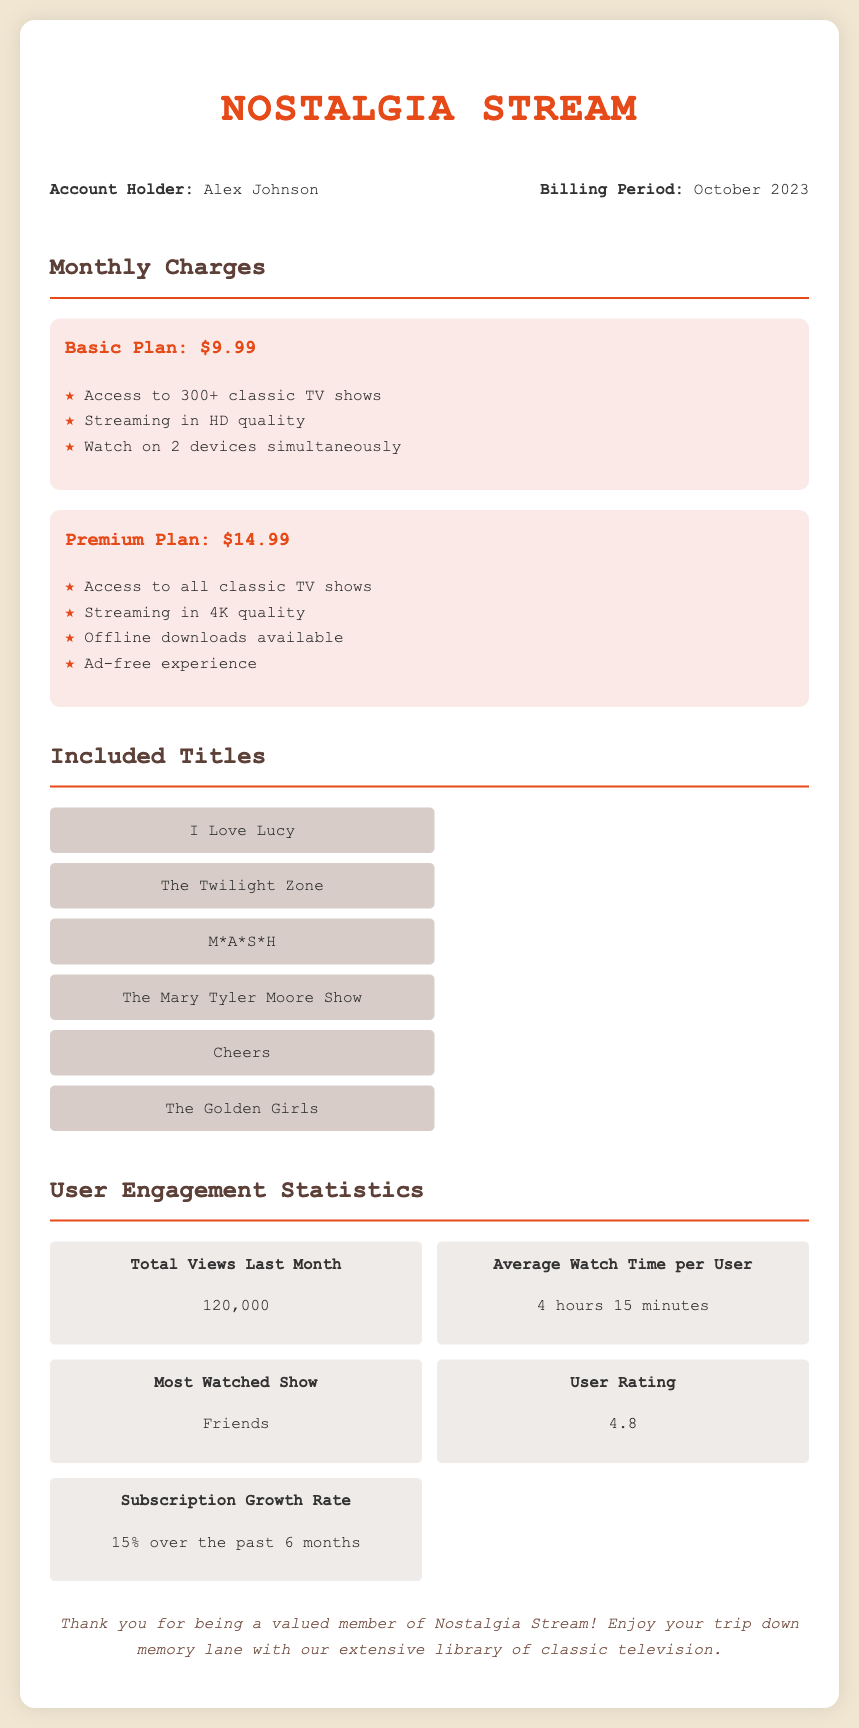what is the account holder's name? The account holder's name is stated in the document as Alex Johnson.
Answer: Alex Johnson what is the monthly charge for the Premium Plan? The document clearly states the monthly charge for the Premium Plan as $14.99.
Answer: $14.99 how many classic TV shows can be accessed with the Basic Plan? According to the information in the document, the Basic Plan provides access to 300+ classic TV shows.
Answer: 300+ what is the most watched show according to user engagement statistics? The document specifies that the most watched show is Friends.
Answer: Friends what is the average watch time per user? The average watch time per user is presented in the user engagement section as 4 hours 15 minutes.
Answer: 4 hours 15 minutes what is the user rating for the service? The document states the user rating as 4.8 in the user engagement statistics section.
Answer: 4.8 what features are included in the Premium Plan? The document outlines the features of the Premium Plan, which includes streaming in 4K quality, offline downloads, and an ad-free experience.
Answer: Streaming in 4K quality, offline downloads, and ad-free experience how much has the subscription growth rate been over the past six months? The document indicates a subscription growth rate of 15% over the past six months.
Answer: 15% what is the total number of views last month? The total number of views last month is mentioned in the user engagement statistics section as 120,000.
Answer: 120,000 